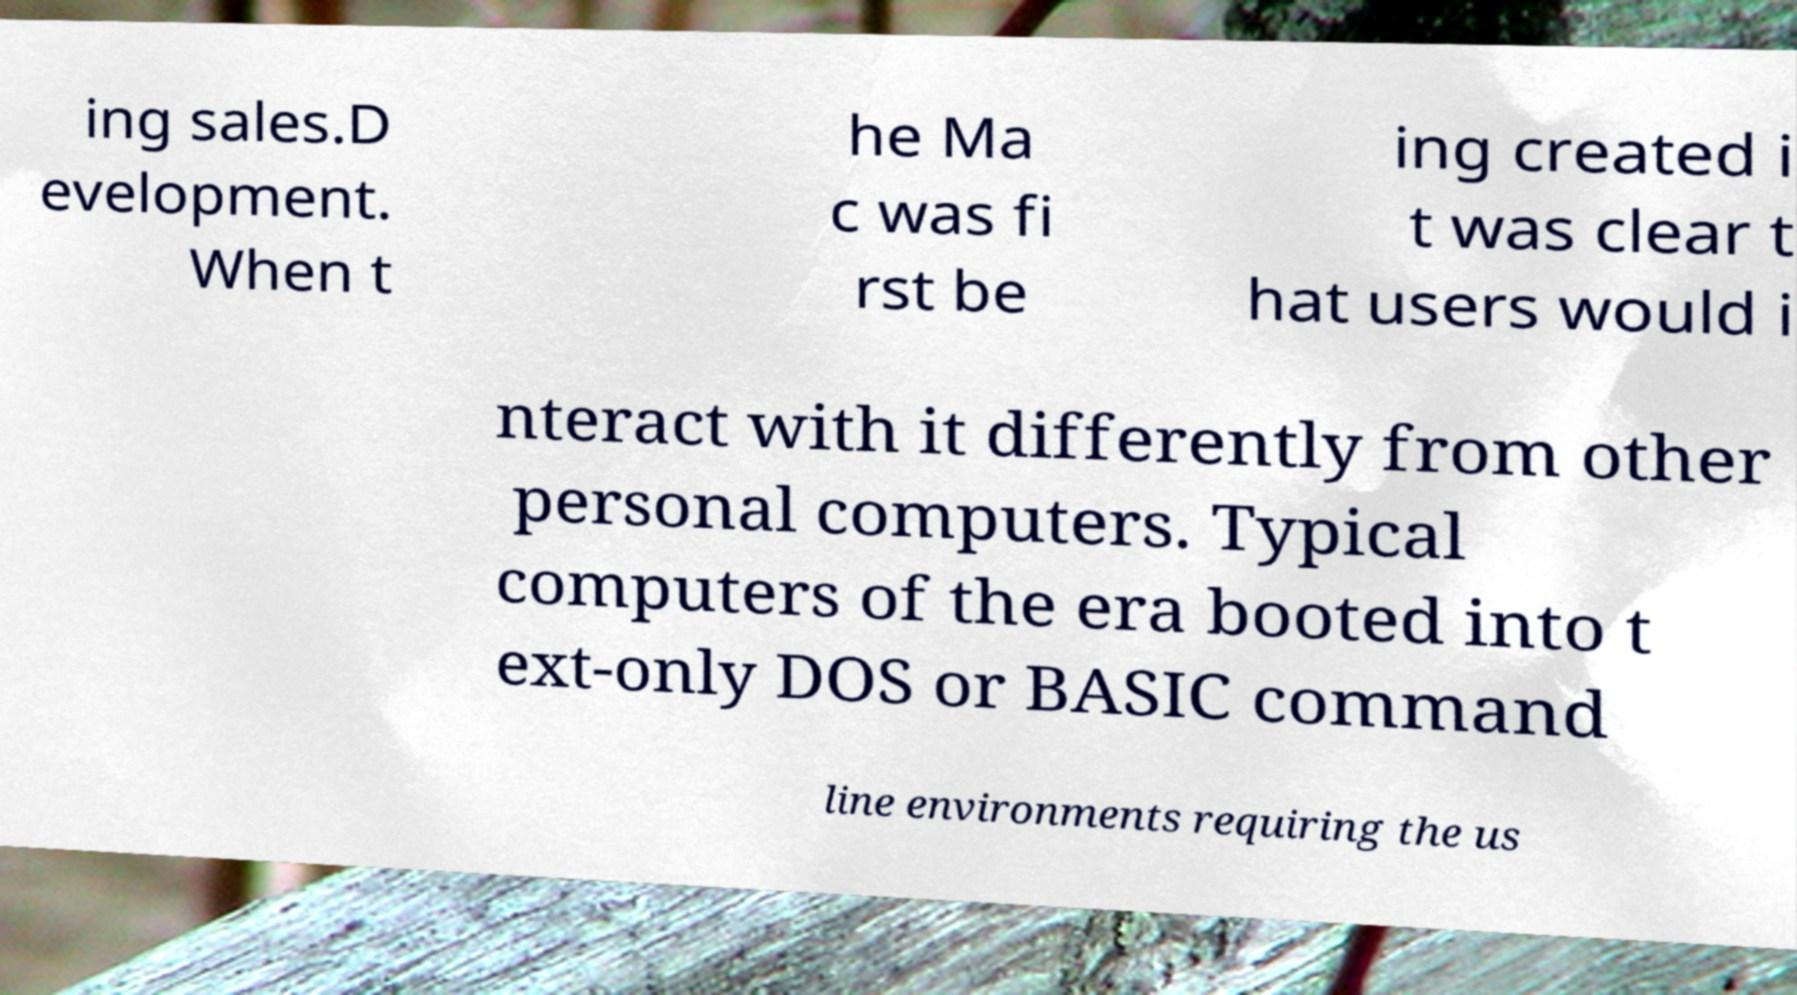There's text embedded in this image that I need extracted. Can you transcribe it verbatim? ing sales.D evelopment. When t he Ma c was fi rst be ing created i t was clear t hat users would i nteract with it differently from other personal computers. Typical computers of the era booted into t ext-only DOS or BASIC command line environments requiring the us 